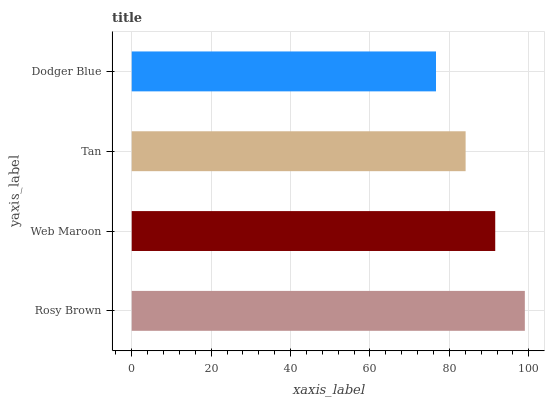Is Dodger Blue the minimum?
Answer yes or no. Yes. Is Rosy Brown the maximum?
Answer yes or no. Yes. Is Web Maroon the minimum?
Answer yes or no. No. Is Web Maroon the maximum?
Answer yes or no. No. Is Rosy Brown greater than Web Maroon?
Answer yes or no. Yes. Is Web Maroon less than Rosy Brown?
Answer yes or no. Yes. Is Web Maroon greater than Rosy Brown?
Answer yes or no. No. Is Rosy Brown less than Web Maroon?
Answer yes or no. No. Is Web Maroon the high median?
Answer yes or no. Yes. Is Tan the low median?
Answer yes or no. Yes. Is Tan the high median?
Answer yes or no. No. Is Dodger Blue the low median?
Answer yes or no. No. 